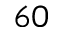<formula> <loc_0><loc_0><loc_500><loc_500>^ { 6 0 }</formula> 